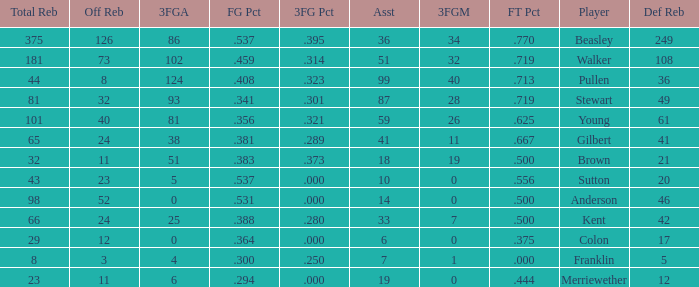Parse the full table. {'header': ['Total Reb', 'Off Reb', '3FGA', 'FG Pct', '3FG Pct', 'Asst', '3FGM', 'FT Pct', 'Player', 'Def Reb'], 'rows': [['375', '126', '86', '.537', '.395', '36', '34', '.770', 'Beasley', '249'], ['181', '73', '102', '.459', '.314', '51', '32', '.719', 'Walker', '108'], ['44', '8', '124', '.408', '.323', '99', '40', '.713', 'Pullen', '36'], ['81', '32', '93', '.341', '.301', '87', '28', '.719', 'Stewart', '49'], ['101', '40', '81', '.356', '.321', '59', '26', '.625', 'Young', '61'], ['65', '24', '38', '.381', '.289', '41', '11', '.667', 'Gilbert', '41'], ['32', '11', '51', '.383', '.373', '18', '19', '.500', 'Brown', '21'], ['43', '23', '5', '.537', '.000', '10', '0', '.556', 'Sutton', '20'], ['98', '52', '0', '.531', '.000', '14', '0', '.500', 'Anderson', '46'], ['66', '24', '25', '.388', '.280', '33', '7', '.500', 'Kent', '42'], ['29', '12', '0', '.364', '.000', '6', '0', '.375', 'Colon', '17'], ['8', '3', '4', '.300', '.250', '7', '1', '.000', 'Franklin', '5'], ['23', '11', '6', '.294', '.000', '19', '0', '.444', 'Merriewether', '12']]} How many FG percent values are associated with 59 assists and offensive rebounds under 40? 0.0. 